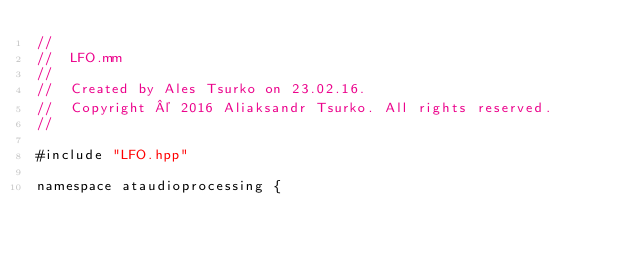<code> <loc_0><loc_0><loc_500><loc_500><_ObjectiveC_>//
//  LFO.mm
//
//  Created by Ales Tsurko on 23.02.16.
//  Copyright © 2016 Aliaksandr Tsurko. All rights reserved.
//

#include "LFO.hpp"

namespace ataudioprocessing {
    </code> 